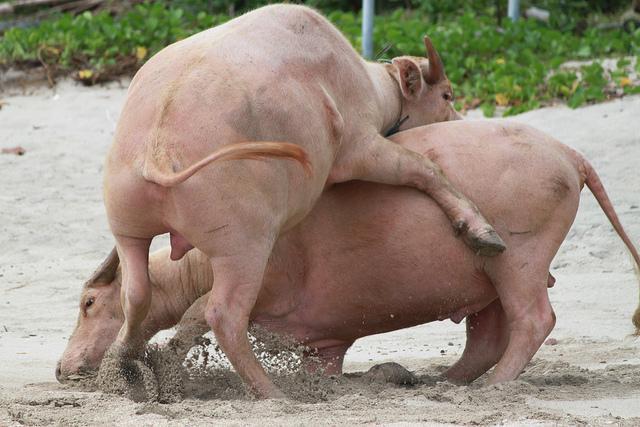How many cows are there?
Give a very brief answer. 2. 